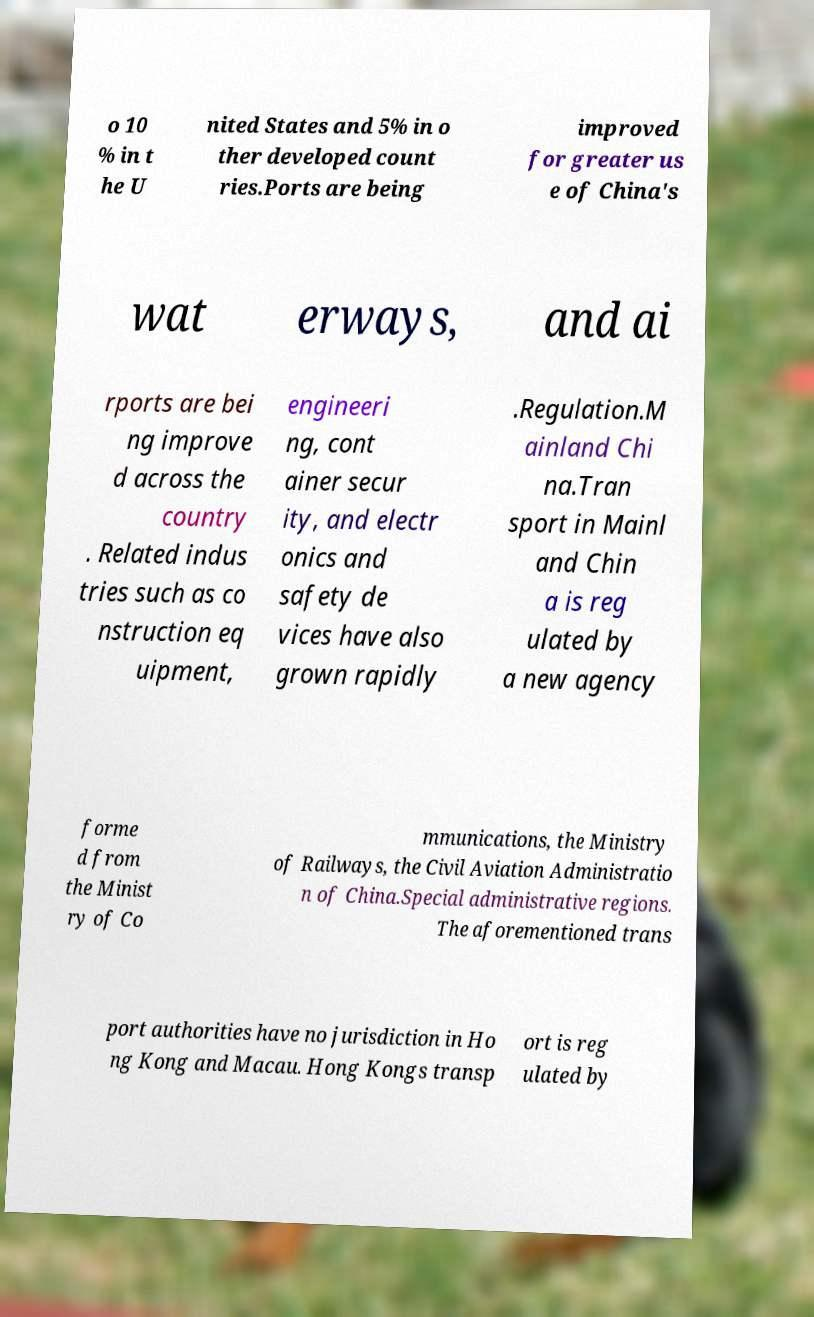Could you extract and type out the text from this image? o 10 % in t he U nited States and 5% in o ther developed count ries.Ports are being improved for greater us e of China's wat erways, and ai rports are bei ng improve d across the country . Related indus tries such as co nstruction eq uipment, engineeri ng, cont ainer secur ity, and electr onics and safety de vices have also grown rapidly .Regulation.M ainland Chi na.Tran sport in Mainl and Chin a is reg ulated by a new agency forme d from the Minist ry of Co mmunications, the Ministry of Railways, the Civil Aviation Administratio n of China.Special administrative regions. The aforementioned trans port authorities have no jurisdiction in Ho ng Kong and Macau. Hong Kongs transp ort is reg ulated by 